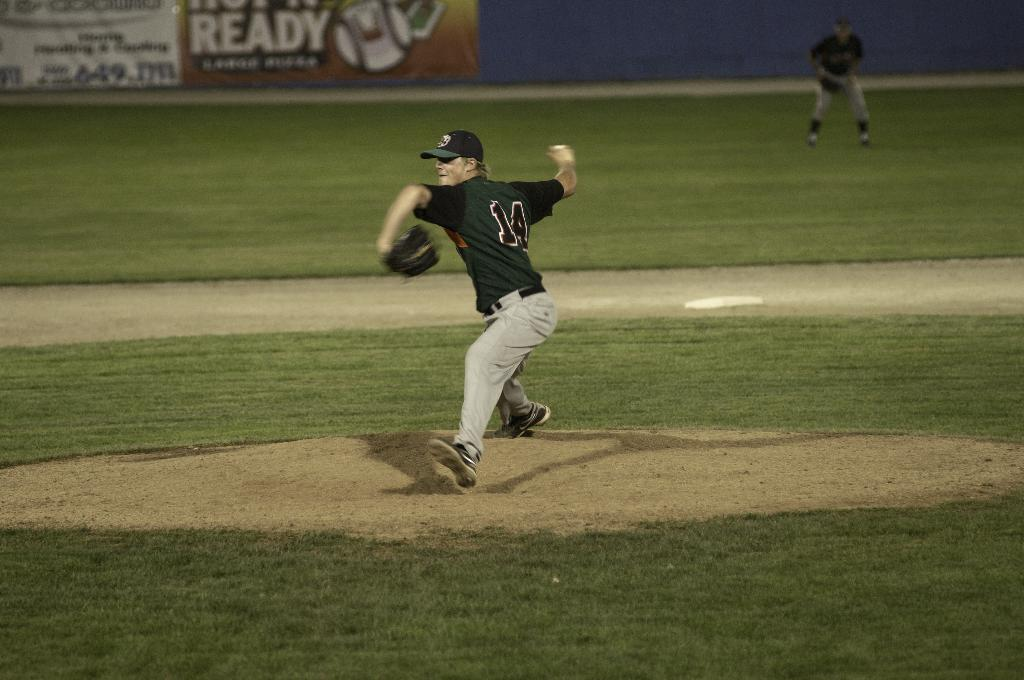<image>
Relay a brief, clear account of the picture shown. A pitcher in a navy blue shirt with the number 14 is throwing a pitch. 